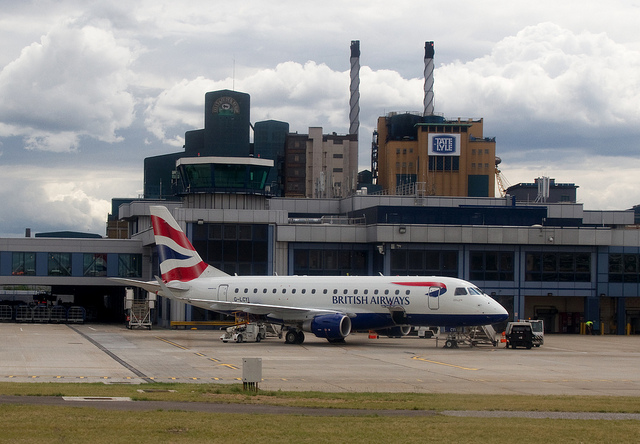How many smoke stacks are in the background? There are two smokestacks visible in the background, towering over the buildings amidst the partly cloudy sky. 